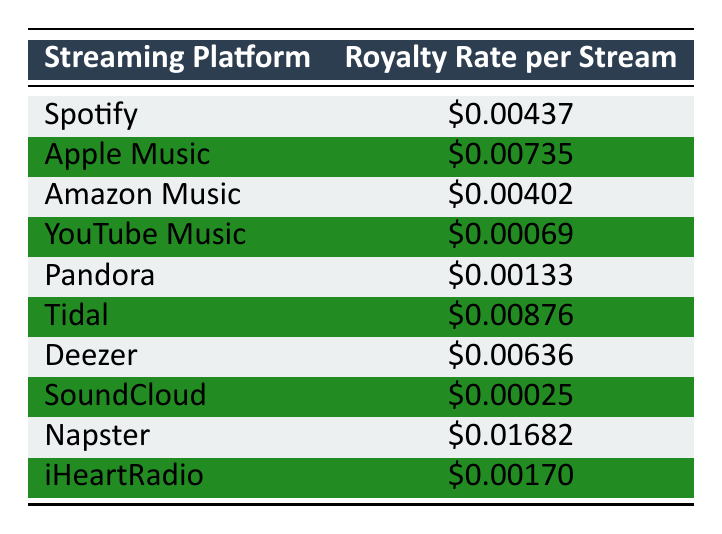What is the royalty rate for Spotify? The table directly lists the royalty rate for Spotify as $0.00437.
Answer: $0.00437 Which streaming platform has the highest royalty rate? According to the table, Napster has the highest royalty rate at $0.01682, as it is the largest value among all entries.
Answer: Napster What is the average royalty rate from the platforms listed? The royalty rates are summed: (0.00437 + 0.00735 + 0.00402 + 0.00069 + 0.00133 + 0.00876 + 0.00636 + 0.00025 + 0.01682 + 0.00170) = 0.05058. There are 10 streaming platforms, so the average is 0.05058 / 10 = 0.005058.
Answer: $0.00506 Is Tidal's royalty rate higher than Apple Music's? The table shows Tidal's rate is $0.00876 and Apple Music's is $0.00735. Comparing these shows Tidal is indeed higher than Apple Music.
Answer: Yes Which platform has a royalty rate lower than $0.001? From the table, both SoundCloud with $0.00025 and YouTube Music with $0.00069 have rates lower than $0.001.
Answer: SoundCloud, YouTube Music What is the total royalty rate for Spotify, Amazon Music, and Pandora combined? Adding the rates of Spotify ($0.00437), Amazon Music ($0.00402), and Pandora ($0.00133), we get $0.00437 + $0.00402 + $0.00133 = $0.00972.
Answer: $0.00972 Do any streaming platforms have a royalty rate greater than $0.007? The table indicates that both Apple Music ($0.00735) and Tidal ($0.00876) have royalty rates greater than $0.007.
Answer: Yes Calculate the difference between Napster's and YouTube Music's royalty rates. Napster's rate is $0.01682 and YouTube Music's rate is $0.00069. The difference is $0.01682 - $0.00069 = $0.01613.
Answer: $0.01613 Which streaming platform's royalty rate is closest to $0.001? Among the listed platforms, Pandora with $0.00133 is closest to $0.001, as this is the nearest rate when compared to others.
Answer: Pandora 